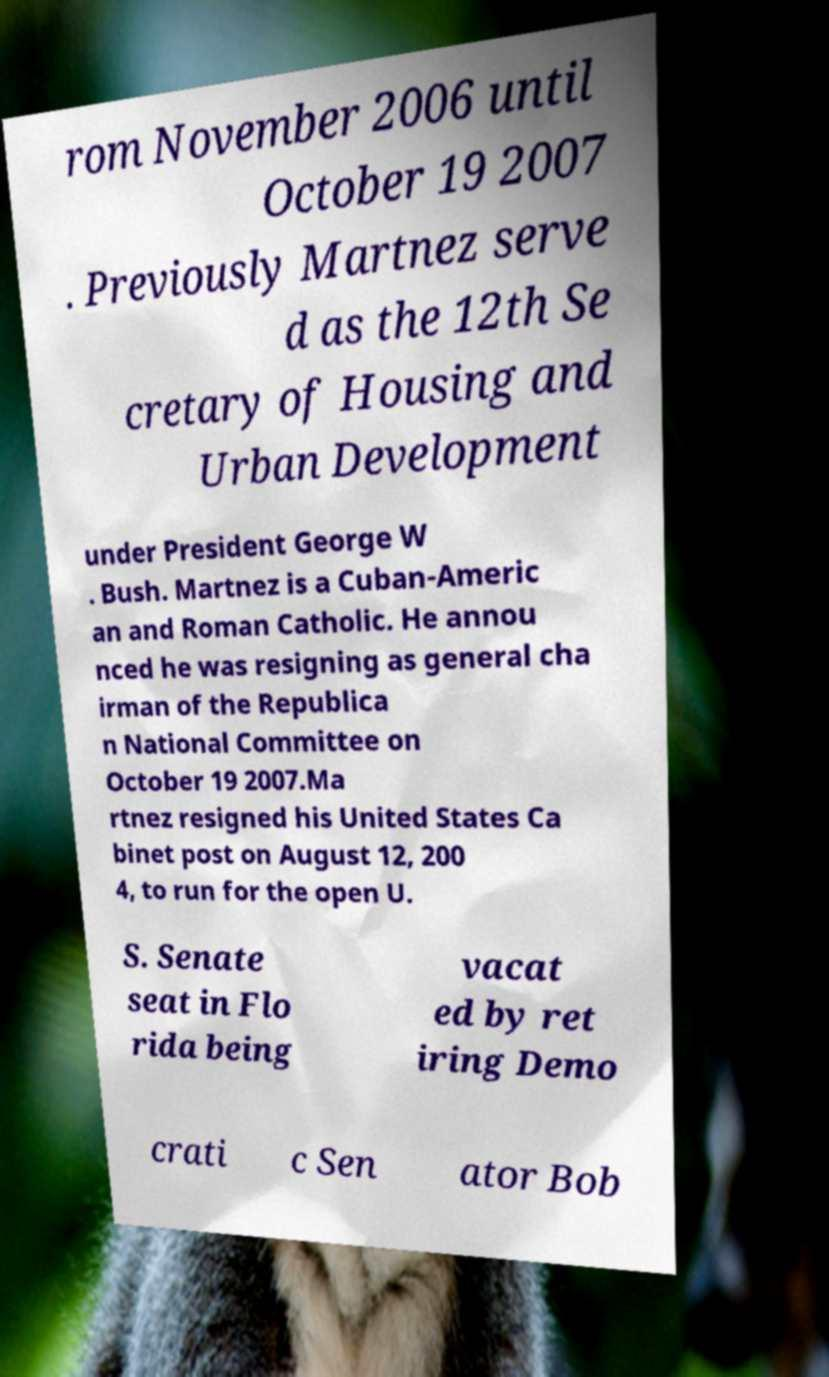Can you accurately transcribe the text from the provided image for me? rom November 2006 until October 19 2007 . Previously Martnez serve d as the 12th Se cretary of Housing and Urban Development under President George W . Bush. Martnez is a Cuban-Americ an and Roman Catholic. He annou nced he was resigning as general cha irman of the Republica n National Committee on October 19 2007.Ma rtnez resigned his United States Ca binet post on August 12, 200 4, to run for the open U. S. Senate seat in Flo rida being vacat ed by ret iring Demo crati c Sen ator Bob 